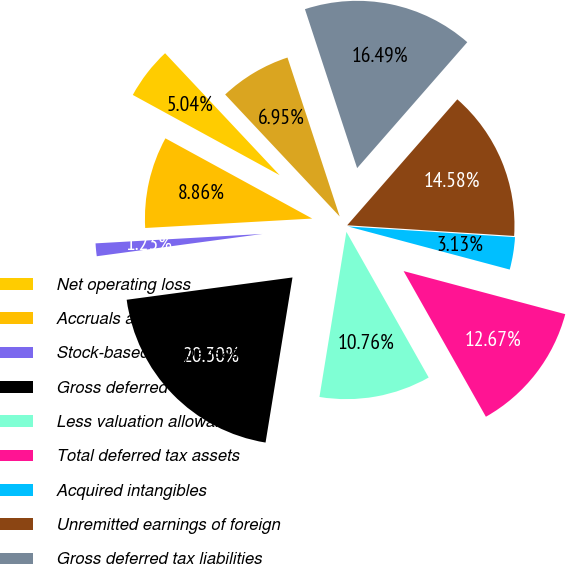<chart> <loc_0><loc_0><loc_500><loc_500><pie_chart><fcel>Net operating loss<fcel>Accruals and reserves not<fcel>Stock-based compensation<fcel>Gross deferred tax assets<fcel>Less valuation allowance<fcel>Total deferred tax assets<fcel>Acquired intangibles<fcel>Unremitted earnings of foreign<fcel>Gross deferred tax liabilities<fcel>Net deferred tax liability<nl><fcel>5.04%<fcel>8.86%<fcel>1.23%<fcel>20.3%<fcel>10.76%<fcel>12.67%<fcel>3.13%<fcel>14.58%<fcel>16.49%<fcel>6.95%<nl></chart> 